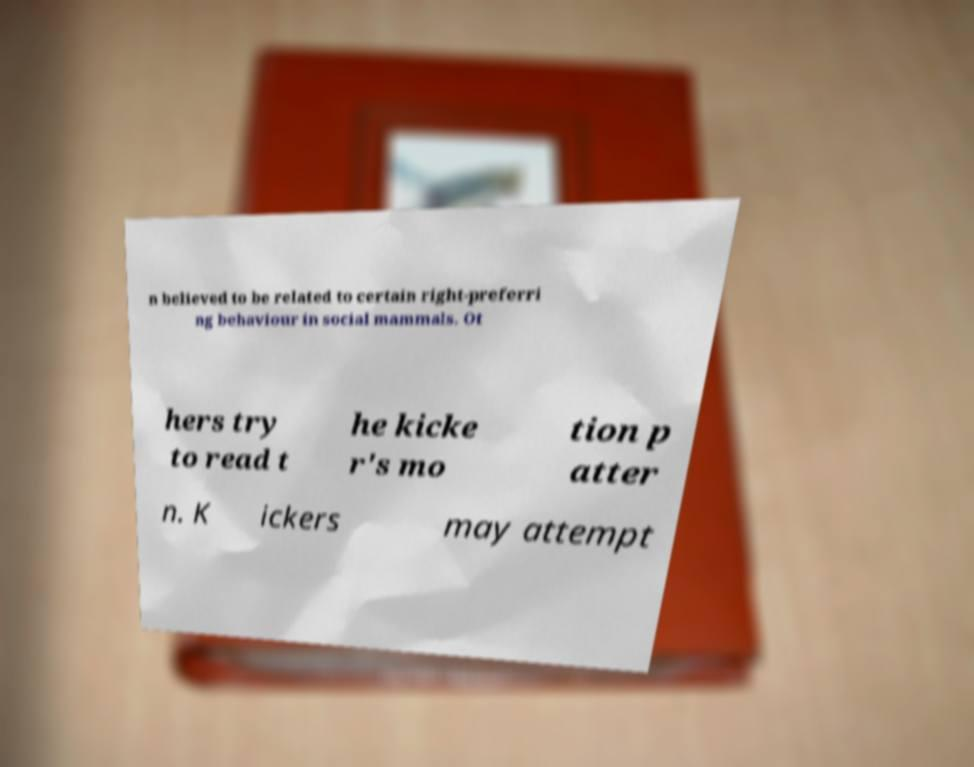For documentation purposes, I need the text within this image transcribed. Could you provide that? n believed to be related to certain right-preferri ng behaviour in social mammals. Ot hers try to read t he kicke r's mo tion p atter n. K ickers may attempt 